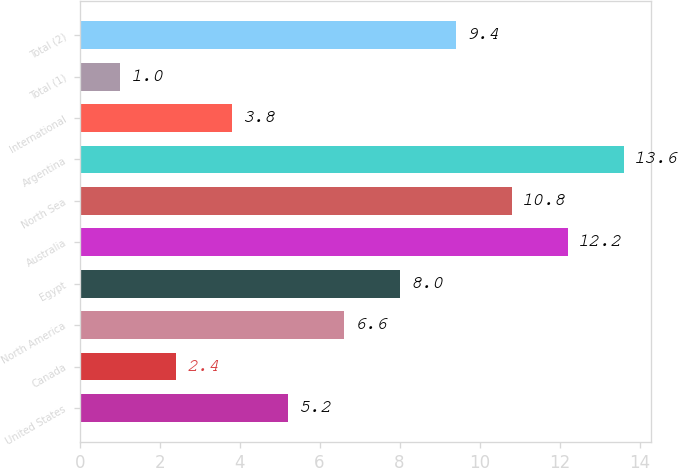Convert chart. <chart><loc_0><loc_0><loc_500><loc_500><bar_chart><fcel>United States<fcel>Canada<fcel>North America<fcel>Egypt<fcel>Australia<fcel>North Sea<fcel>Argentina<fcel>International<fcel>Total (1)<fcel>Total (2)<nl><fcel>5.2<fcel>2.4<fcel>6.6<fcel>8<fcel>12.2<fcel>10.8<fcel>13.6<fcel>3.8<fcel>1<fcel>9.4<nl></chart> 